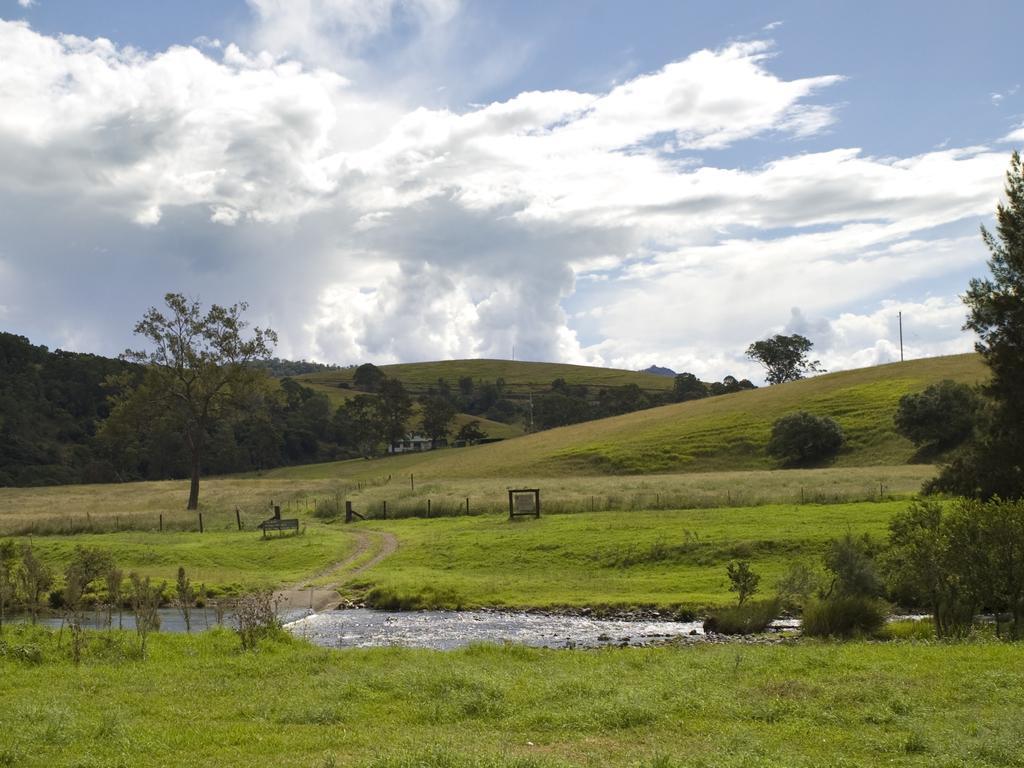Can you describe this image briefly? In this image we can see plants and grass on the ground, water and small poles. In the background we can see trees, houses, grass, hills, pole and clouds in the sky. 